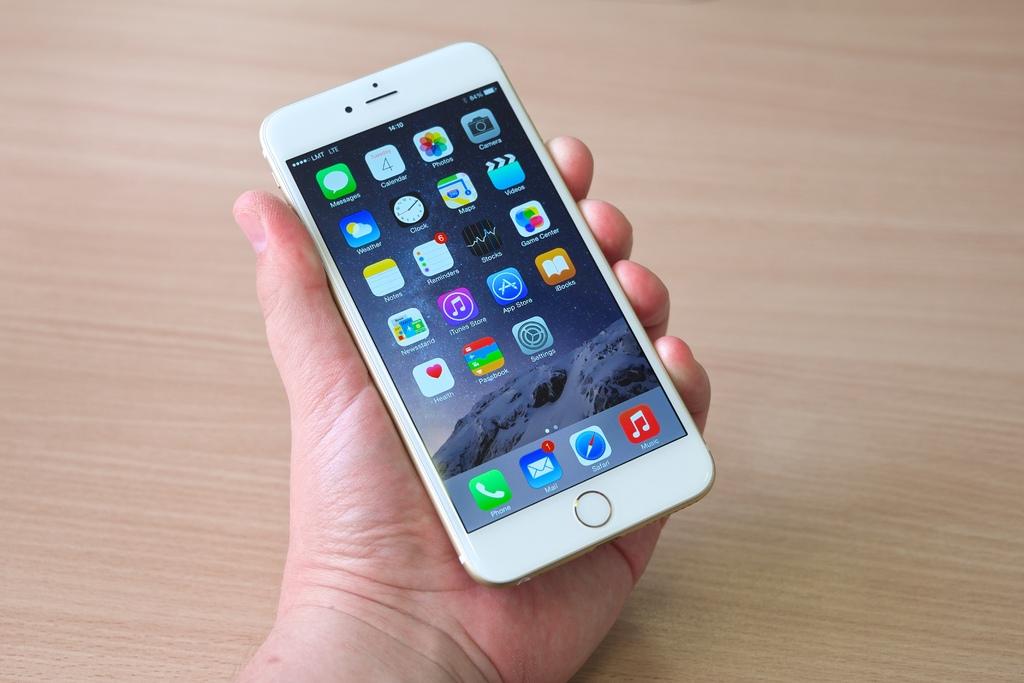What app does the bottom red button bring up?
Your response must be concise. Music. What internet browser is loaded on the phone?
Your response must be concise. Safari. 